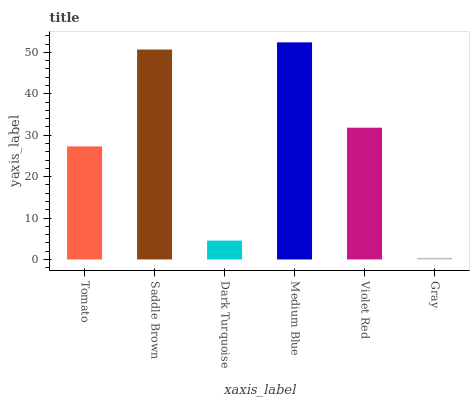Is Gray the minimum?
Answer yes or no. Yes. Is Medium Blue the maximum?
Answer yes or no. Yes. Is Saddle Brown the minimum?
Answer yes or no. No. Is Saddle Brown the maximum?
Answer yes or no. No. Is Saddle Brown greater than Tomato?
Answer yes or no. Yes. Is Tomato less than Saddle Brown?
Answer yes or no. Yes. Is Tomato greater than Saddle Brown?
Answer yes or no. No. Is Saddle Brown less than Tomato?
Answer yes or no. No. Is Violet Red the high median?
Answer yes or no. Yes. Is Tomato the low median?
Answer yes or no. Yes. Is Saddle Brown the high median?
Answer yes or no. No. Is Medium Blue the low median?
Answer yes or no. No. 